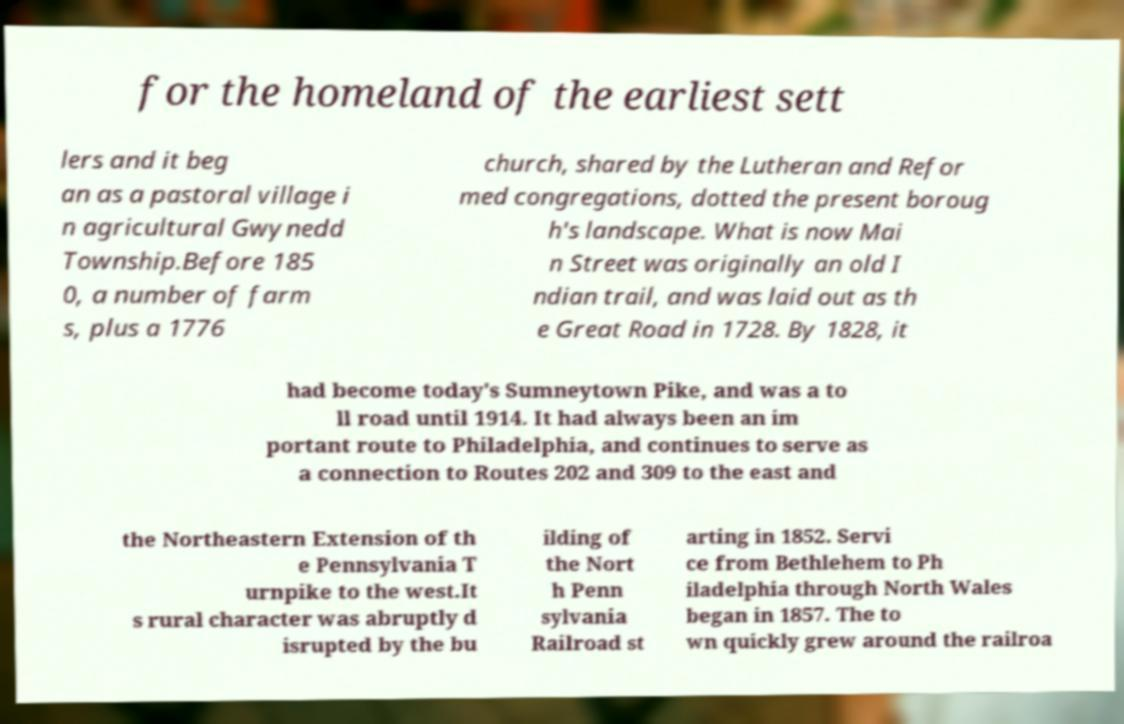I need the written content from this picture converted into text. Can you do that? for the homeland of the earliest sett lers and it beg an as a pastoral village i n agricultural Gwynedd Township.Before 185 0, a number of farm s, plus a 1776 church, shared by the Lutheran and Refor med congregations, dotted the present boroug h's landscape. What is now Mai n Street was originally an old I ndian trail, and was laid out as th e Great Road in 1728. By 1828, it had become today's Sumneytown Pike, and was a to ll road until 1914. It had always been an im portant route to Philadelphia, and continues to serve as a connection to Routes 202 and 309 to the east and the Northeastern Extension of th e Pennsylvania T urnpike to the west.It s rural character was abruptly d isrupted by the bu ilding of the Nort h Penn sylvania Railroad st arting in 1852. Servi ce from Bethlehem to Ph iladelphia through North Wales began in 1857. The to wn quickly grew around the railroa 